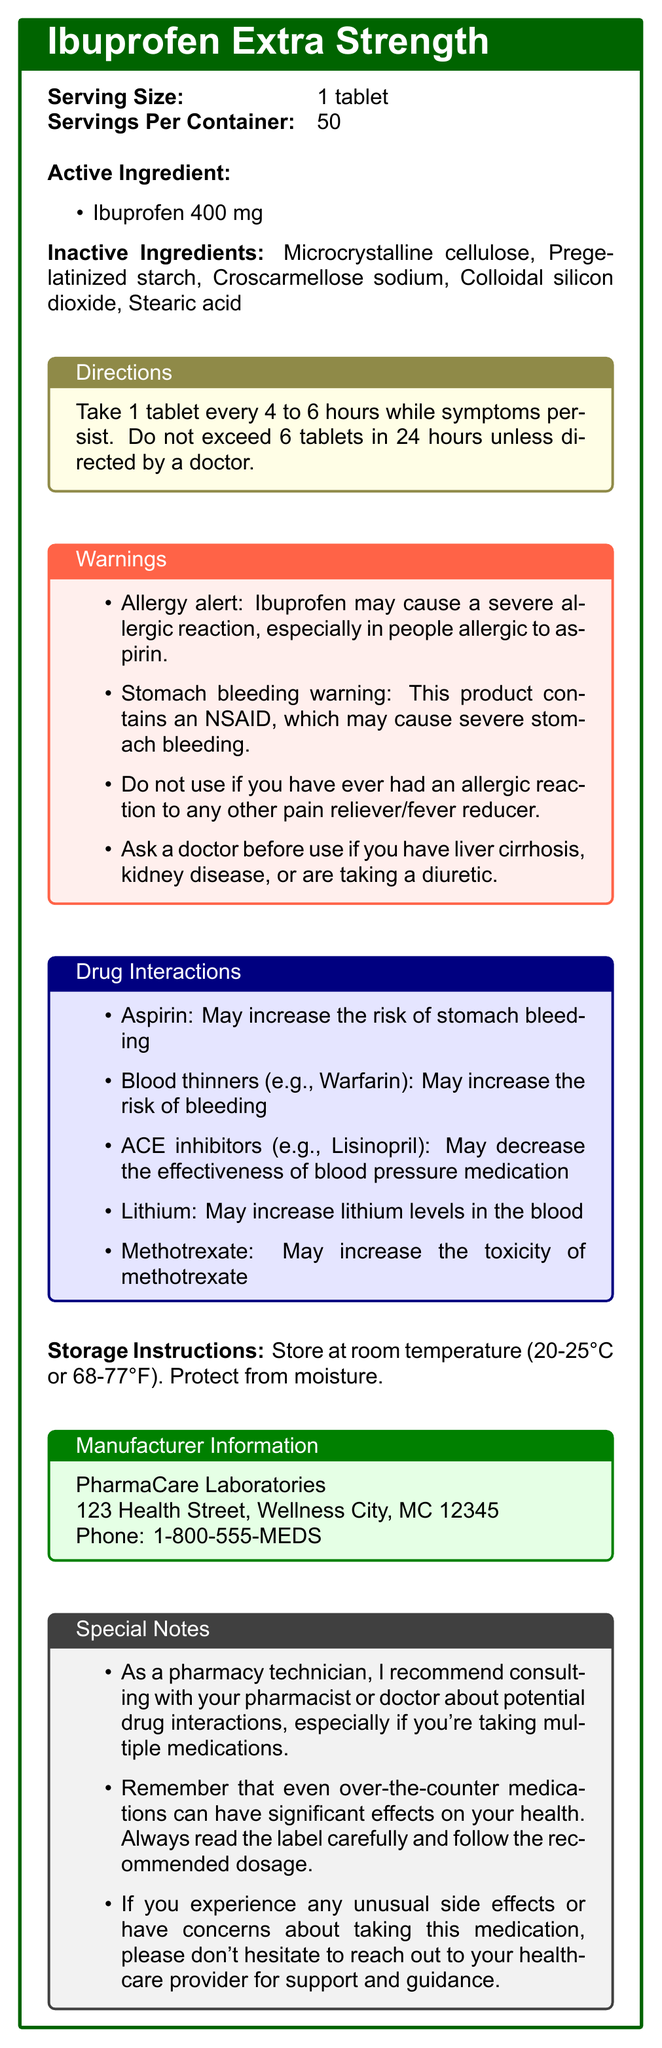How many tablets of Ibuprofen Extra Strength are in one container? The document states that there are 50 servings per container, and each serving size is 1 tablet.
Answer: 50 What is the active ingredient in Ibuprofen Extra Strength and its amount? The active ingredient listed is Ibuprofen, with an amount of 400 mg per tablet.
Answer: Ibuprofen, 400 mg List all the inactive ingredients in this medication. The document includes a list of inactive ingredients, which are Microcrystalline cellulose, Pregelatinized starch, Croscarmellose sodium, Colloidal silicon dioxide, and Stearic acid.
Answer: Microcrystalline cellulose, Pregelatinized starch, Croscarmellose sodium, Colloidal silicon dioxide, Stearic acid What should you do if you have liver cirrhosis before using this medication? The warnings section states to ask a doctor before use if you have liver cirrhosis.
Answer: Ask a doctor before use How often can you take a tablet of Ibuprofen Extra Strength? The directions specify to take one tablet every 4 to 6 hours while symptoms persist.
Answer: Every 4 to 6 hours What is a potential risk of using Ibuprofen Extra Strength for someone also taking aspirin? A. Increased risk of liver damage B. Increased risk of stomach bleeding C. Decreased effectiveness of aspirin D. No interactions Under the drug interactions section, it states that taking Aspirin with Ibuprofen may increase the risk of stomach bleeding.
Answer: B Which of the following medications may increase the risk of bleeding when taken with Ibuprofen Extra Strength? A. Blood thinners (e.g., Warfarin) B. ACE inhibitors (e.g., Lisinopril) C. Lithium D. Methotrexate The drug interactions section clearly states that blood thinners (e.g., Warfarin) may increase the risk of bleeding.
Answer: A Can Ibuprofen Extra Strength be used by individuals allergic to aspirin? The warnings section indicates that Ibuprofen may cause a severe allergic reaction, especially in people allergic to aspirin.
Answer: No Summarize the main points of the Ibuprofen Extra Strength Nutrition Facts Label. This summary covers all major sections of the document including the active and inactive ingredients, usage directions, warnings, drug interactions, storage instructions, and manufacturer information.
Answer: The document provides information about Ibuprofen Extra Strength, which contains 400 mg of Ibuprofen per tablet. It also lists inactive ingredients and usage directions, emphasizes warnings such as allergy alerts and stomach bleeding risks, and notes potential drug interactions with medications like Aspirin, Blood thinners, ACE inhibitors, Lithium, and Methotrexate. Storage instructions and manufacturer contact details are also provided. What is the temperature range for storing Ibuprofen Extra Strength? The storage instructions specify that the medication should be stored at room temperature, between 20-25°C or 68-77°F.
Answer: 20-25°C or 68-77°F Who manufactures Ibuprofen Extra Strength? The manufacturer information box lists PharmaCare Laboratories as the manufacturer.
Answer: PharmaCare Laboratories What interaction does Ibuprofen have with Methotrexate? The drug interactions section indicates that Ibuprofen may increase the toxicity of Methotrexate.
Answer: May increase the toxicity of Methotrexate What should you do if you need to take more than the recommended dosage of Ibuprofen Extra Strength? The directions state not to exceed 6 tablets in 24 hours unless directed by a doctor.
Answer: Consult a doctor How much Ibuprofen is in each tablet of this medication? The active ingredient section specifies that each tablet contains 400 mg of Ibuprofen.
Answer: 400 mg Where is PharmaCare Laboratories located? The manufacturer information provides the address of PharmaCare Laboratories.
Answer: 123 Health Street, Wellness City, MC 12345 What are some special notes for customers provided by the pharmacy technician? The special notes section advises customers to consult with their healthcare provider about potential drug interactions, follow the label instructions, and contact their healthcare provider if they experience any side effects or have concerns about the medication.
Answer: Consult your pharmacist or doctor about drug interactions, always read the label and follow the dosage, reach out to healthcare provider if experiencing side effects or concerns. Is it safe to use this medication if you have kidney disease? The warnings section advises asking a doctor before use if you have kidney disease.
Answer: Ask a doctor before use What is the phone number for PharmaCare Laboratories? The manufacturer information box lists the phone number as 1-800-555-MEDS.
Answer: 1-800-555-MEDS What is the recommended action if you have diuretic medications and want to use this product? According to the warnings section, you should ask a doctor before using Ibuprofen Extra Strength if you are taking a diuretic.
Answer: Ask a doctor before use Can the specific dosage schedule of Ibuprofen Extra Strength be tailored by a healthcare provider? The directions note not to exceed 6 tablets in 24 hours unless directed by a doctor.
Answer: Yes What is the relationship between Ibuprofen and lithium levels? The drug interactions section specifies that Ibuprofen may increase lithium levels in the blood.
Answer: May increase lithium levels in the blood What is the amount of Pregelatinized starch in each tablet? The document lists Pregelatinized starch as an inactive ingredient but does not specify the amount.
Answer: Not listed 